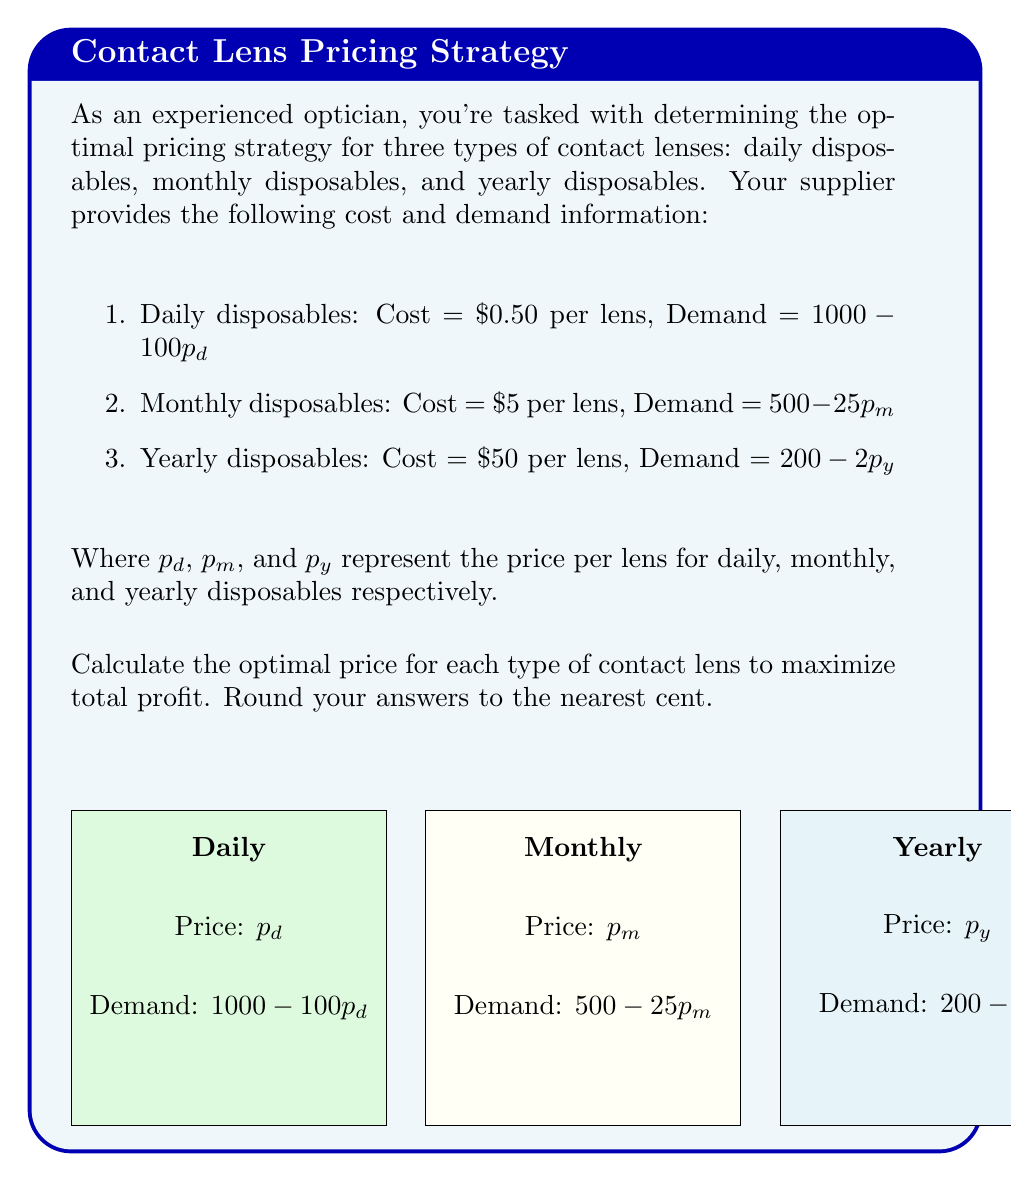Provide a solution to this math problem. To find the optimal price for each type of contact lens, we need to maximize the profit function for each. Let's solve this step-by-step:

1. For daily disposables:
   Profit function: $\pi_d = (p_d - 0.50)(1000 - 100p_d)$
   Expand: $\pi_d = 1000p_d - 100p_d^2 - 500 + 50p_d = -100p_d^2 + 1050p_d - 500$
   To maximize, set derivative to zero: $\frac{d\pi_d}{dp_d} = -200p_d + 1050 = 0$
   Solve: $p_d = \frac{1050}{200} = 5.25$

2. For monthly disposables:
   Profit function: $\pi_m = (p_m - 5)(500 - 25p_m)$
   Expand: $\pi_m = 500p_m - 25p_m^2 - 2500 + 125p_m = -25p_m^2 + 625p_m - 2500$
   To maximize, set derivative to zero: $\frac{d\pi_m}{dp_m} = -50p_m + 625 = 0$
   Solve: $p_m = \frac{625}{50} = 12.50$

3. For yearly disposables:
   Profit function: $\pi_y = (p_y - 50)(200 - 2p_y)$
   Expand: $\pi_y = 200p_y - 2p_y^2 - 10000 + 100p_y = -2p_y^2 + 300p_y - 10000$
   To maximize, set derivative to zero: $\frac{d\pi_y}{dp_y} = -4p_y + 300 = 0$
   Solve: $p_y = \frac{300}{4} = 75$

Rounding to the nearest cent:
Daily disposables: $5.25
Monthly disposables: $12.50
Yearly disposables: $75.00
Answer: Daily: $5.25, Monthly: $12.50, Yearly: $75.00 